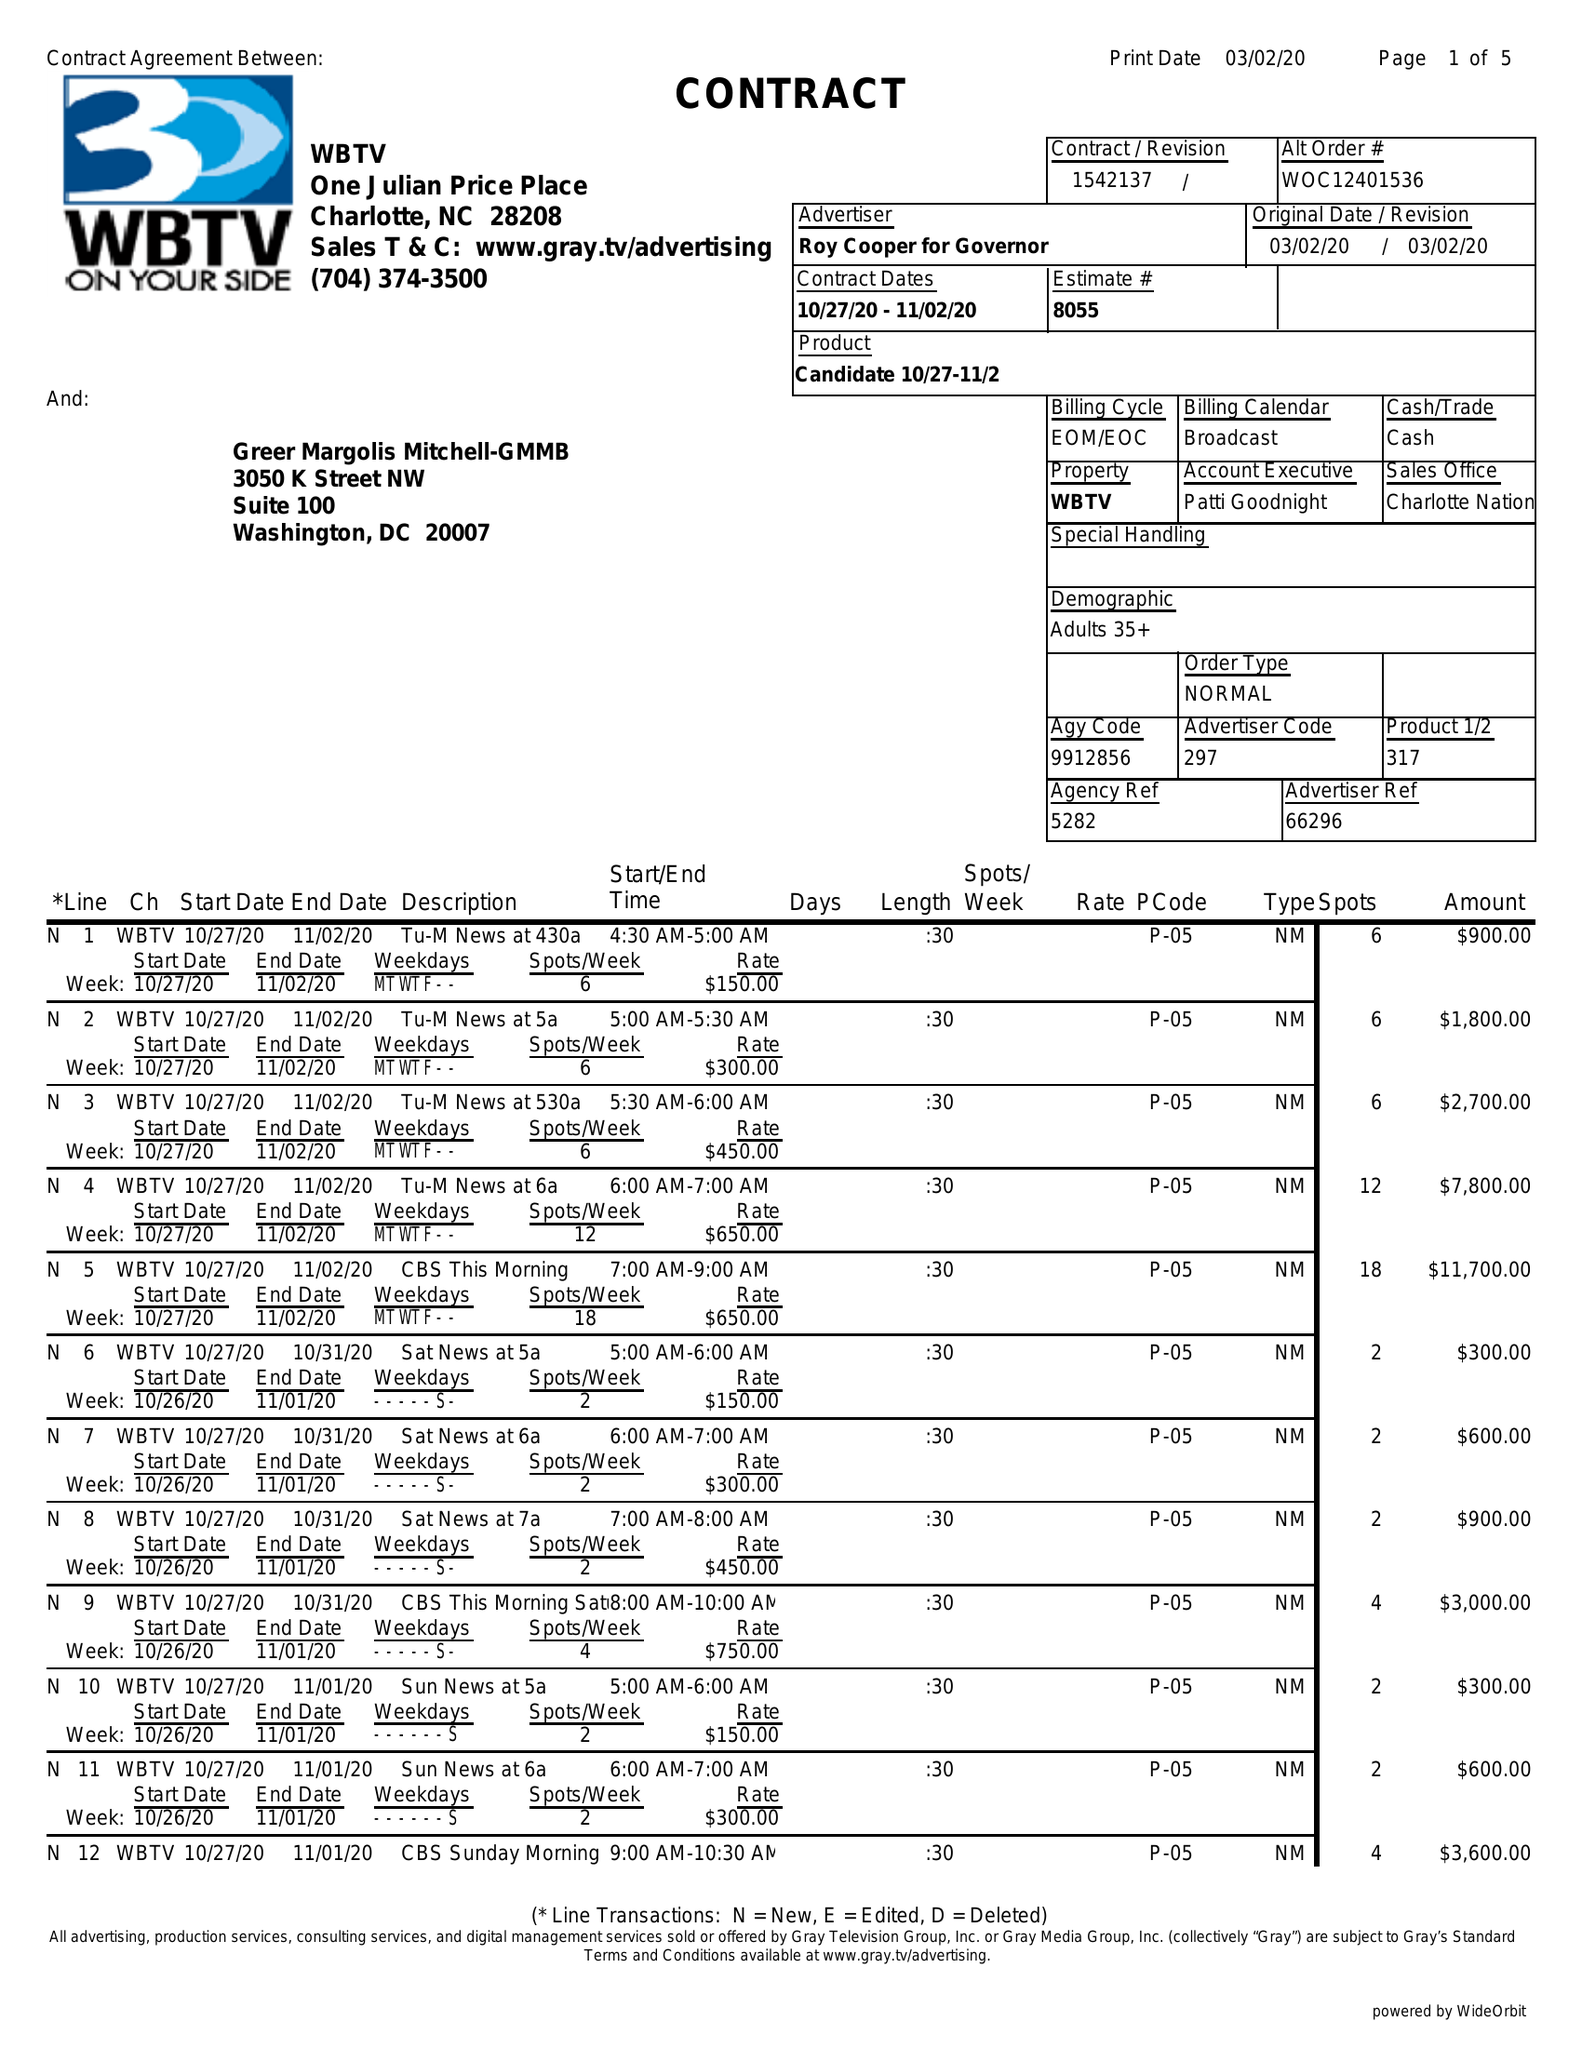What is the value for the gross_amount?
Answer the question using a single word or phrase. 210300.00 